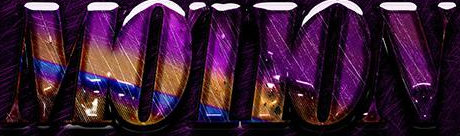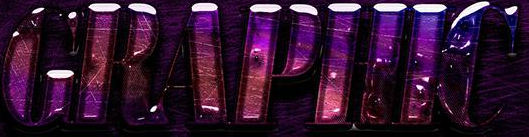What text is displayed in these images sequentially, separated by a semicolon? MOTION; GRAPHIC 